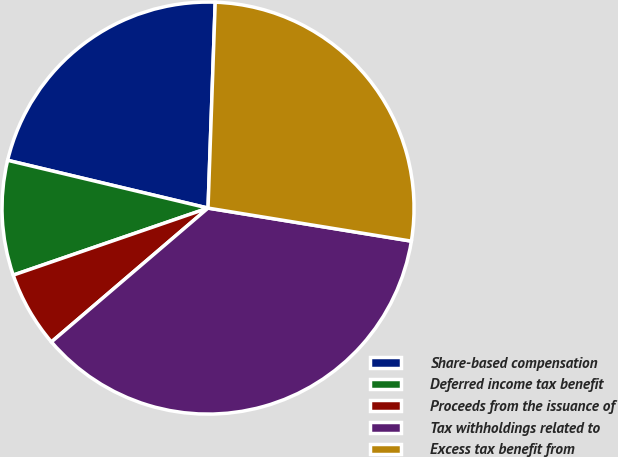<chart> <loc_0><loc_0><loc_500><loc_500><pie_chart><fcel>Share-based compensation<fcel>Deferred income tax benefit<fcel>Proceeds from the issuance of<fcel>Tax withholdings related to<fcel>Excess tax benefit from<nl><fcel>21.83%<fcel>9.0%<fcel>5.98%<fcel>36.18%<fcel>27.01%<nl></chart> 